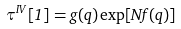Convert formula to latex. <formula><loc_0><loc_0><loc_500><loc_500>\tau ^ { I V } [ 1 ] = g ( q ) \exp [ N f ( q ) ]</formula> 